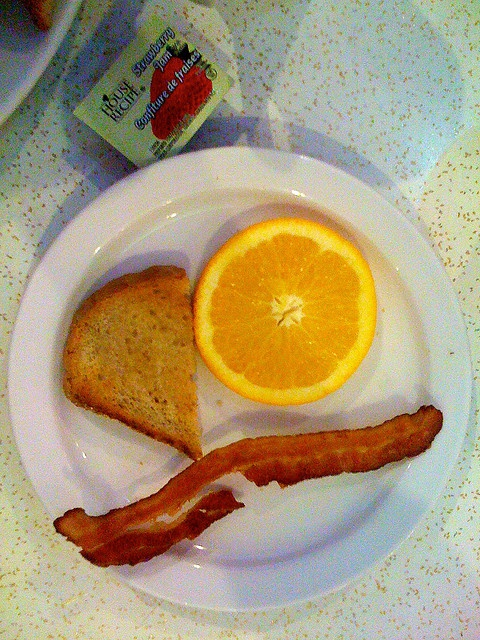Describe the objects in this image and their specific colors. I can see a orange in black, orange, and gold tones in this image. 